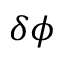<formula> <loc_0><loc_0><loc_500><loc_500>\delta \phi</formula> 